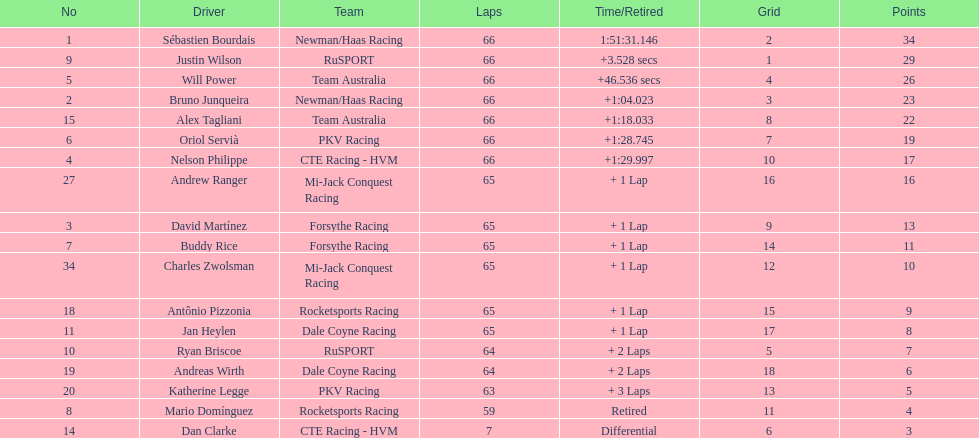Who finished directly after the driver who finished in 1:28.745? Nelson Philippe. 